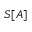<formula> <loc_0><loc_0><loc_500><loc_500>S [ A ]</formula> 